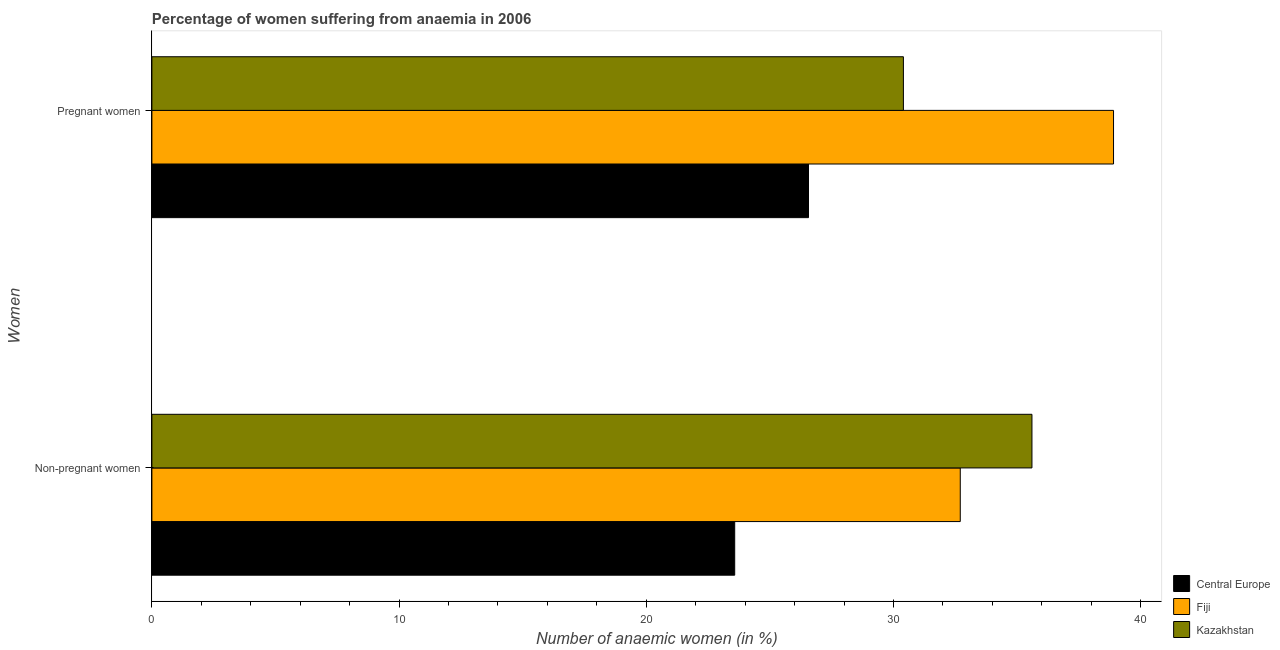How many groups of bars are there?
Give a very brief answer. 2. Are the number of bars per tick equal to the number of legend labels?
Your response must be concise. Yes. How many bars are there on the 2nd tick from the bottom?
Keep it short and to the point. 3. What is the label of the 2nd group of bars from the top?
Provide a short and direct response. Non-pregnant women. What is the percentage of non-pregnant anaemic women in Kazakhstan?
Provide a short and direct response. 35.6. Across all countries, what is the maximum percentage of non-pregnant anaemic women?
Ensure brevity in your answer.  35.6. Across all countries, what is the minimum percentage of non-pregnant anaemic women?
Provide a succinct answer. 23.58. In which country was the percentage of pregnant anaemic women maximum?
Offer a very short reply. Fiji. In which country was the percentage of pregnant anaemic women minimum?
Make the answer very short. Central Europe. What is the total percentage of pregnant anaemic women in the graph?
Keep it short and to the point. 95.86. What is the difference between the percentage of non-pregnant anaemic women in Kazakhstan and that in Central Europe?
Offer a terse response. 12.02. What is the difference between the percentage of non-pregnant anaemic women in Fiji and the percentage of pregnant anaemic women in Kazakhstan?
Provide a short and direct response. 2.3. What is the average percentage of pregnant anaemic women per country?
Make the answer very short. 31.95. What is the difference between the percentage of non-pregnant anaemic women and percentage of pregnant anaemic women in Central Europe?
Make the answer very short. -2.99. What is the ratio of the percentage of non-pregnant anaemic women in Central Europe to that in Fiji?
Your answer should be compact. 0.72. What does the 1st bar from the top in Pregnant women represents?
Your answer should be very brief. Kazakhstan. What does the 1st bar from the bottom in Non-pregnant women represents?
Give a very brief answer. Central Europe. What is the difference between two consecutive major ticks on the X-axis?
Make the answer very short. 10. Does the graph contain any zero values?
Your response must be concise. No. Does the graph contain grids?
Your response must be concise. No. Where does the legend appear in the graph?
Offer a terse response. Bottom right. How many legend labels are there?
Ensure brevity in your answer.  3. How are the legend labels stacked?
Make the answer very short. Vertical. What is the title of the graph?
Give a very brief answer. Percentage of women suffering from anaemia in 2006. What is the label or title of the X-axis?
Offer a very short reply. Number of anaemic women (in %). What is the label or title of the Y-axis?
Make the answer very short. Women. What is the Number of anaemic women (in %) of Central Europe in Non-pregnant women?
Provide a short and direct response. 23.58. What is the Number of anaemic women (in %) of Fiji in Non-pregnant women?
Provide a short and direct response. 32.7. What is the Number of anaemic women (in %) of Kazakhstan in Non-pregnant women?
Provide a short and direct response. 35.6. What is the Number of anaemic women (in %) in Central Europe in Pregnant women?
Make the answer very short. 26.56. What is the Number of anaemic women (in %) of Fiji in Pregnant women?
Your response must be concise. 38.9. What is the Number of anaemic women (in %) of Kazakhstan in Pregnant women?
Make the answer very short. 30.4. Across all Women, what is the maximum Number of anaemic women (in %) of Central Europe?
Give a very brief answer. 26.56. Across all Women, what is the maximum Number of anaemic women (in %) in Fiji?
Offer a terse response. 38.9. Across all Women, what is the maximum Number of anaemic women (in %) in Kazakhstan?
Keep it short and to the point. 35.6. Across all Women, what is the minimum Number of anaemic women (in %) of Central Europe?
Provide a short and direct response. 23.58. Across all Women, what is the minimum Number of anaemic women (in %) in Fiji?
Offer a very short reply. 32.7. Across all Women, what is the minimum Number of anaemic women (in %) of Kazakhstan?
Provide a short and direct response. 30.4. What is the total Number of anaemic women (in %) in Central Europe in the graph?
Give a very brief answer. 50.14. What is the total Number of anaemic women (in %) of Fiji in the graph?
Provide a succinct answer. 71.6. What is the total Number of anaemic women (in %) in Kazakhstan in the graph?
Your answer should be compact. 66. What is the difference between the Number of anaemic women (in %) of Central Europe in Non-pregnant women and that in Pregnant women?
Make the answer very short. -2.99. What is the difference between the Number of anaemic women (in %) in Central Europe in Non-pregnant women and the Number of anaemic women (in %) in Fiji in Pregnant women?
Offer a very short reply. -15.32. What is the difference between the Number of anaemic women (in %) of Central Europe in Non-pregnant women and the Number of anaemic women (in %) of Kazakhstan in Pregnant women?
Offer a very short reply. -6.82. What is the average Number of anaemic women (in %) of Central Europe per Women?
Provide a short and direct response. 25.07. What is the average Number of anaemic women (in %) of Fiji per Women?
Make the answer very short. 35.8. What is the difference between the Number of anaemic women (in %) in Central Europe and Number of anaemic women (in %) in Fiji in Non-pregnant women?
Provide a short and direct response. -9.12. What is the difference between the Number of anaemic women (in %) of Central Europe and Number of anaemic women (in %) of Kazakhstan in Non-pregnant women?
Your response must be concise. -12.02. What is the difference between the Number of anaemic women (in %) in Central Europe and Number of anaemic women (in %) in Fiji in Pregnant women?
Provide a short and direct response. -12.34. What is the difference between the Number of anaemic women (in %) of Central Europe and Number of anaemic women (in %) of Kazakhstan in Pregnant women?
Give a very brief answer. -3.84. What is the difference between the Number of anaemic women (in %) in Fiji and Number of anaemic women (in %) in Kazakhstan in Pregnant women?
Ensure brevity in your answer.  8.5. What is the ratio of the Number of anaemic women (in %) of Central Europe in Non-pregnant women to that in Pregnant women?
Your response must be concise. 0.89. What is the ratio of the Number of anaemic women (in %) of Fiji in Non-pregnant women to that in Pregnant women?
Keep it short and to the point. 0.84. What is the ratio of the Number of anaemic women (in %) of Kazakhstan in Non-pregnant women to that in Pregnant women?
Your response must be concise. 1.17. What is the difference between the highest and the second highest Number of anaemic women (in %) in Central Europe?
Make the answer very short. 2.99. What is the difference between the highest and the lowest Number of anaemic women (in %) in Central Europe?
Offer a very short reply. 2.99. 